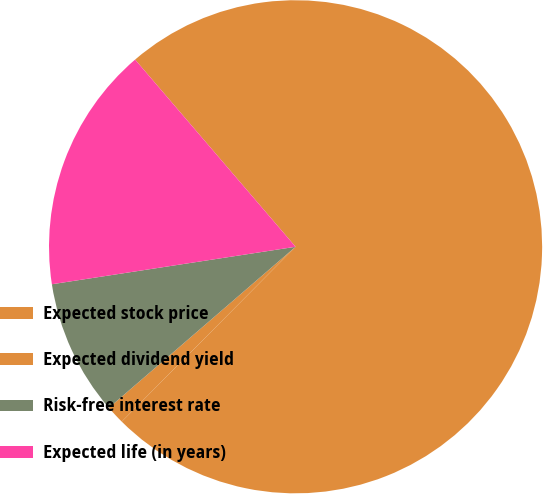<chart> <loc_0><loc_0><loc_500><loc_500><pie_chart><fcel>Expected stock price<fcel>Expected dividend yield<fcel>Risk-free interest rate<fcel>Expected life (in years)<nl><fcel>73.74%<fcel>1.22%<fcel>8.9%<fcel>16.15%<nl></chart> 